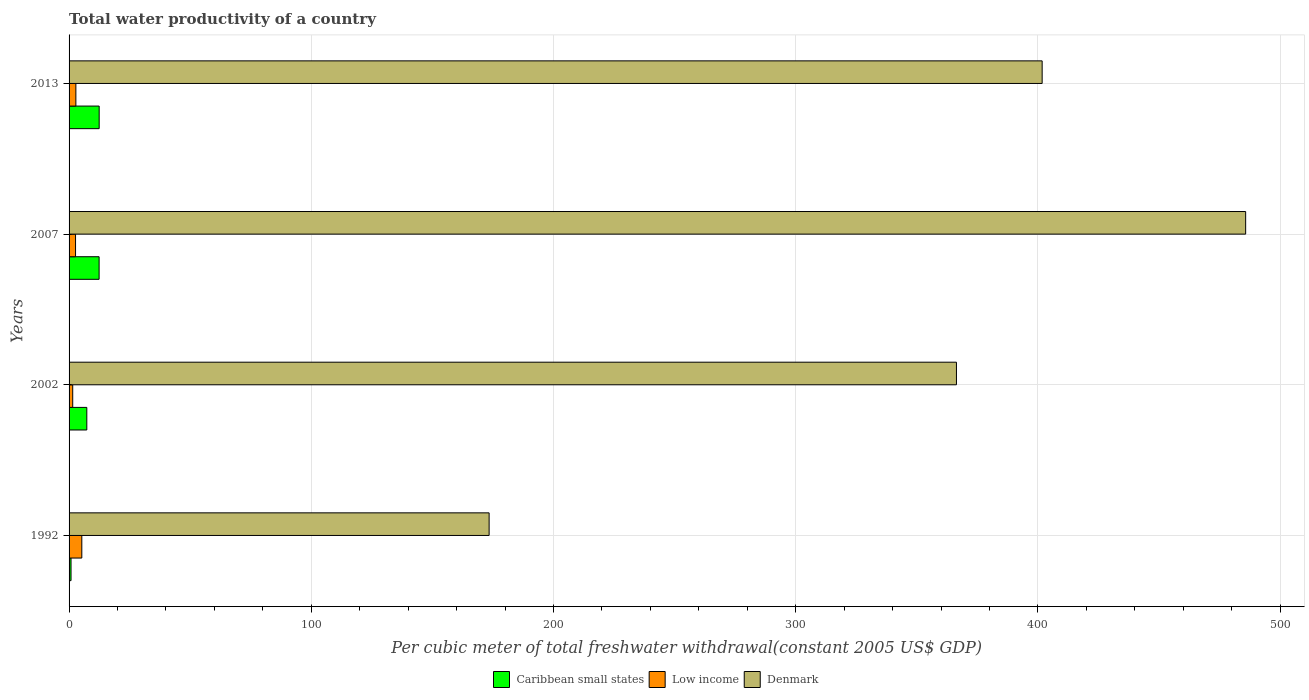How many groups of bars are there?
Your answer should be very brief. 4. How many bars are there on the 1st tick from the bottom?
Your answer should be compact. 3. What is the total water productivity in Caribbean small states in 1992?
Make the answer very short. 0.81. Across all years, what is the maximum total water productivity in Caribbean small states?
Ensure brevity in your answer.  12.43. Across all years, what is the minimum total water productivity in Caribbean small states?
Ensure brevity in your answer.  0.81. In which year was the total water productivity in Caribbean small states maximum?
Your answer should be compact. 2013. What is the total total water productivity in Caribbean small states in the graph?
Offer a terse response. 32.95. What is the difference between the total water productivity in Denmark in 2007 and that in 2013?
Make the answer very short. 84.01. What is the difference between the total water productivity in Low income in 1992 and the total water productivity in Denmark in 2007?
Keep it short and to the point. -480.47. What is the average total water productivity in Low income per year?
Make the answer very short. 3.06. In the year 2007, what is the difference between the total water productivity in Denmark and total water productivity in Low income?
Give a very brief answer. 483.06. What is the ratio of the total water productivity in Low income in 2002 to that in 2007?
Offer a terse response. 0.56. What is the difference between the highest and the second highest total water productivity in Caribbean small states?
Provide a succinct answer. 0.03. What is the difference between the highest and the lowest total water productivity in Denmark?
Give a very brief answer. 312.32. In how many years, is the total water productivity in Low income greater than the average total water productivity in Low income taken over all years?
Ensure brevity in your answer.  1. What does the 2nd bar from the top in 2002 represents?
Your answer should be very brief. Low income. Is it the case that in every year, the sum of the total water productivity in Caribbean small states and total water productivity in Denmark is greater than the total water productivity in Low income?
Your response must be concise. Yes. How many bars are there?
Make the answer very short. 12. Are all the bars in the graph horizontal?
Your response must be concise. Yes. How many years are there in the graph?
Your response must be concise. 4. Does the graph contain grids?
Make the answer very short. Yes. Where does the legend appear in the graph?
Keep it short and to the point. Bottom center. How are the legend labels stacked?
Offer a terse response. Horizontal. What is the title of the graph?
Provide a succinct answer. Total water productivity of a country. Does "Cabo Verde" appear as one of the legend labels in the graph?
Provide a succinct answer. No. What is the label or title of the X-axis?
Provide a short and direct response. Per cubic meter of total freshwater withdrawal(constant 2005 US$ GDP). What is the label or title of the Y-axis?
Make the answer very short. Years. What is the Per cubic meter of total freshwater withdrawal(constant 2005 US$ GDP) of Caribbean small states in 1992?
Keep it short and to the point. 0.81. What is the Per cubic meter of total freshwater withdrawal(constant 2005 US$ GDP) of Low income in 1992?
Ensure brevity in your answer.  5.26. What is the Per cubic meter of total freshwater withdrawal(constant 2005 US$ GDP) of Denmark in 1992?
Offer a very short reply. 173.41. What is the Per cubic meter of total freshwater withdrawal(constant 2005 US$ GDP) of Caribbean small states in 2002?
Ensure brevity in your answer.  7.32. What is the Per cubic meter of total freshwater withdrawal(constant 2005 US$ GDP) of Low income in 2002?
Offer a very short reply. 1.51. What is the Per cubic meter of total freshwater withdrawal(constant 2005 US$ GDP) of Denmark in 2002?
Keep it short and to the point. 366.34. What is the Per cubic meter of total freshwater withdrawal(constant 2005 US$ GDP) in Caribbean small states in 2007?
Provide a succinct answer. 12.4. What is the Per cubic meter of total freshwater withdrawal(constant 2005 US$ GDP) of Low income in 2007?
Offer a terse response. 2.67. What is the Per cubic meter of total freshwater withdrawal(constant 2005 US$ GDP) in Denmark in 2007?
Make the answer very short. 485.73. What is the Per cubic meter of total freshwater withdrawal(constant 2005 US$ GDP) in Caribbean small states in 2013?
Provide a succinct answer. 12.43. What is the Per cubic meter of total freshwater withdrawal(constant 2005 US$ GDP) in Low income in 2013?
Offer a very short reply. 2.81. What is the Per cubic meter of total freshwater withdrawal(constant 2005 US$ GDP) of Denmark in 2013?
Make the answer very short. 401.72. Across all years, what is the maximum Per cubic meter of total freshwater withdrawal(constant 2005 US$ GDP) of Caribbean small states?
Your answer should be compact. 12.43. Across all years, what is the maximum Per cubic meter of total freshwater withdrawal(constant 2005 US$ GDP) in Low income?
Ensure brevity in your answer.  5.26. Across all years, what is the maximum Per cubic meter of total freshwater withdrawal(constant 2005 US$ GDP) in Denmark?
Keep it short and to the point. 485.73. Across all years, what is the minimum Per cubic meter of total freshwater withdrawal(constant 2005 US$ GDP) in Caribbean small states?
Your answer should be very brief. 0.81. Across all years, what is the minimum Per cubic meter of total freshwater withdrawal(constant 2005 US$ GDP) in Low income?
Offer a terse response. 1.51. Across all years, what is the minimum Per cubic meter of total freshwater withdrawal(constant 2005 US$ GDP) in Denmark?
Offer a very short reply. 173.41. What is the total Per cubic meter of total freshwater withdrawal(constant 2005 US$ GDP) of Caribbean small states in the graph?
Provide a succinct answer. 32.95. What is the total Per cubic meter of total freshwater withdrawal(constant 2005 US$ GDP) in Low income in the graph?
Make the answer very short. 12.26. What is the total Per cubic meter of total freshwater withdrawal(constant 2005 US$ GDP) of Denmark in the graph?
Provide a succinct answer. 1427.21. What is the difference between the Per cubic meter of total freshwater withdrawal(constant 2005 US$ GDP) in Caribbean small states in 1992 and that in 2002?
Provide a succinct answer. -6.51. What is the difference between the Per cubic meter of total freshwater withdrawal(constant 2005 US$ GDP) of Low income in 1992 and that in 2002?
Provide a succinct answer. 3.75. What is the difference between the Per cubic meter of total freshwater withdrawal(constant 2005 US$ GDP) in Denmark in 1992 and that in 2002?
Your answer should be very brief. -192.92. What is the difference between the Per cubic meter of total freshwater withdrawal(constant 2005 US$ GDP) in Caribbean small states in 1992 and that in 2007?
Keep it short and to the point. -11.59. What is the difference between the Per cubic meter of total freshwater withdrawal(constant 2005 US$ GDP) in Low income in 1992 and that in 2007?
Your response must be concise. 2.59. What is the difference between the Per cubic meter of total freshwater withdrawal(constant 2005 US$ GDP) of Denmark in 1992 and that in 2007?
Keep it short and to the point. -312.32. What is the difference between the Per cubic meter of total freshwater withdrawal(constant 2005 US$ GDP) in Caribbean small states in 1992 and that in 2013?
Your answer should be very brief. -11.62. What is the difference between the Per cubic meter of total freshwater withdrawal(constant 2005 US$ GDP) of Low income in 1992 and that in 2013?
Your response must be concise. 2.45. What is the difference between the Per cubic meter of total freshwater withdrawal(constant 2005 US$ GDP) in Denmark in 1992 and that in 2013?
Provide a succinct answer. -228.31. What is the difference between the Per cubic meter of total freshwater withdrawal(constant 2005 US$ GDP) in Caribbean small states in 2002 and that in 2007?
Make the answer very short. -5.08. What is the difference between the Per cubic meter of total freshwater withdrawal(constant 2005 US$ GDP) of Low income in 2002 and that in 2007?
Your answer should be very brief. -1.17. What is the difference between the Per cubic meter of total freshwater withdrawal(constant 2005 US$ GDP) of Denmark in 2002 and that in 2007?
Provide a short and direct response. -119.4. What is the difference between the Per cubic meter of total freshwater withdrawal(constant 2005 US$ GDP) of Caribbean small states in 2002 and that in 2013?
Offer a very short reply. -5.11. What is the difference between the Per cubic meter of total freshwater withdrawal(constant 2005 US$ GDP) of Low income in 2002 and that in 2013?
Ensure brevity in your answer.  -1.3. What is the difference between the Per cubic meter of total freshwater withdrawal(constant 2005 US$ GDP) in Denmark in 2002 and that in 2013?
Provide a short and direct response. -35.39. What is the difference between the Per cubic meter of total freshwater withdrawal(constant 2005 US$ GDP) in Caribbean small states in 2007 and that in 2013?
Make the answer very short. -0.03. What is the difference between the Per cubic meter of total freshwater withdrawal(constant 2005 US$ GDP) of Low income in 2007 and that in 2013?
Your answer should be compact. -0.14. What is the difference between the Per cubic meter of total freshwater withdrawal(constant 2005 US$ GDP) in Denmark in 2007 and that in 2013?
Provide a succinct answer. 84.01. What is the difference between the Per cubic meter of total freshwater withdrawal(constant 2005 US$ GDP) of Caribbean small states in 1992 and the Per cubic meter of total freshwater withdrawal(constant 2005 US$ GDP) of Low income in 2002?
Your response must be concise. -0.7. What is the difference between the Per cubic meter of total freshwater withdrawal(constant 2005 US$ GDP) in Caribbean small states in 1992 and the Per cubic meter of total freshwater withdrawal(constant 2005 US$ GDP) in Denmark in 2002?
Provide a short and direct response. -365.53. What is the difference between the Per cubic meter of total freshwater withdrawal(constant 2005 US$ GDP) in Low income in 1992 and the Per cubic meter of total freshwater withdrawal(constant 2005 US$ GDP) in Denmark in 2002?
Ensure brevity in your answer.  -361.07. What is the difference between the Per cubic meter of total freshwater withdrawal(constant 2005 US$ GDP) in Caribbean small states in 1992 and the Per cubic meter of total freshwater withdrawal(constant 2005 US$ GDP) in Low income in 2007?
Your answer should be very brief. -1.87. What is the difference between the Per cubic meter of total freshwater withdrawal(constant 2005 US$ GDP) in Caribbean small states in 1992 and the Per cubic meter of total freshwater withdrawal(constant 2005 US$ GDP) in Denmark in 2007?
Keep it short and to the point. -484.93. What is the difference between the Per cubic meter of total freshwater withdrawal(constant 2005 US$ GDP) in Low income in 1992 and the Per cubic meter of total freshwater withdrawal(constant 2005 US$ GDP) in Denmark in 2007?
Provide a succinct answer. -480.47. What is the difference between the Per cubic meter of total freshwater withdrawal(constant 2005 US$ GDP) in Caribbean small states in 1992 and the Per cubic meter of total freshwater withdrawal(constant 2005 US$ GDP) in Low income in 2013?
Provide a short and direct response. -2.01. What is the difference between the Per cubic meter of total freshwater withdrawal(constant 2005 US$ GDP) in Caribbean small states in 1992 and the Per cubic meter of total freshwater withdrawal(constant 2005 US$ GDP) in Denmark in 2013?
Provide a succinct answer. -400.92. What is the difference between the Per cubic meter of total freshwater withdrawal(constant 2005 US$ GDP) of Low income in 1992 and the Per cubic meter of total freshwater withdrawal(constant 2005 US$ GDP) of Denmark in 2013?
Offer a terse response. -396.46. What is the difference between the Per cubic meter of total freshwater withdrawal(constant 2005 US$ GDP) of Caribbean small states in 2002 and the Per cubic meter of total freshwater withdrawal(constant 2005 US$ GDP) of Low income in 2007?
Your answer should be compact. 4.65. What is the difference between the Per cubic meter of total freshwater withdrawal(constant 2005 US$ GDP) of Caribbean small states in 2002 and the Per cubic meter of total freshwater withdrawal(constant 2005 US$ GDP) of Denmark in 2007?
Make the answer very short. -478.41. What is the difference between the Per cubic meter of total freshwater withdrawal(constant 2005 US$ GDP) in Low income in 2002 and the Per cubic meter of total freshwater withdrawal(constant 2005 US$ GDP) in Denmark in 2007?
Your response must be concise. -484.23. What is the difference between the Per cubic meter of total freshwater withdrawal(constant 2005 US$ GDP) in Caribbean small states in 2002 and the Per cubic meter of total freshwater withdrawal(constant 2005 US$ GDP) in Low income in 2013?
Your answer should be very brief. 4.51. What is the difference between the Per cubic meter of total freshwater withdrawal(constant 2005 US$ GDP) of Caribbean small states in 2002 and the Per cubic meter of total freshwater withdrawal(constant 2005 US$ GDP) of Denmark in 2013?
Your answer should be very brief. -394.4. What is the difference between the Per cubic meter of total freshwater withdrawal(constant 2005 US$ GDP) in Low income in 2002 and the Per cubic meter of total freshwater withdrawal(constant 2005 US$ GDP) in Denmark in 2013?
Make the answer very short. -400.21. What is the difference between the Per cubic meter of total freshwater withdrawal(constant 2005 US$ GDP) in Caribbean small states in 2007 and the Per cubic meter of total freshwater withdrawal(constant 2005 US$ GDP) in Low income in 2013?
Offer a terse response. 9.59. What is the difference between the Per cubic meter of total freshwater withdrawal(constant 2005 US$ GDP) of Caribbean small states in 2007 and the Per cubic meter of total freshwater withdrawal(constant 2005 US$ GDP) of Denmark in 2013?
Your answer should be very brief. -389.32. What is the difference between the Per cubic meter of total freshwater withdrawal(constant 2005 US$ GDP) in Low income in 2007 and the Per cubic meter of total freshwater withdrawal(constant 2005 US$ GDP) in Denmark in 2013?
Ensure brevity in your answer.  -399.05. What is the average Per cubic meter of total freshwater withdrawal(constant 2005 US$ GDP) in Caribbean small states per year?
Provide a succinct answer. 8.24. What is the average Per cubic meter of total freshwater withdrawal(constant 2005 US$ GDP) in Low income per year?
Make the answer very short. 3.06. What is the average Per cubic meter of total freshwater withdrawal(constant 2005 US$ GDP) in Denmark per year?
Provide a succinct answer. 356.8. In the year 1992, what is the difference between the Per cubic meter of total freshwater withdrawal(constant 2005 US$ GDP) in Caribbean small states and Per cubic meter of total freshwater withdrawal(constant 2005 US$ GDP) in Low income?
Ensure brevity in your answer.  -4.46. In the year 1992, what is the difference between the Per cubic meter of total freshwater withdrawal(constant 2005 US$ GDP) of Caribbean small states and Per cubic meter of total freshwater withdrawal(constant 2005 US$ GDP) of Denmark?
Give a very brief answer. -172.61. In the year 1992, what is the difference between the Per cubic meter of total freshwater withdrawal(constant 2005 US$ GDP) in Low income and Per cubic meter of total freshwater withdrawal(constant 2005 US$ GDP) in Denmark?
Provide a succinct answer. -168.15. In the year 2002, what is the difference between the Per cubic meter of total freshwater withdrawal(constant 2005 US$ GDP) in Caribbean small states and Per cubic meter of total freshwater withdrawal(constant 2005 US$ GDP) in Low income?
Provide a short and direct response. 5.81. In the year 2002, what is the difference between the Per cubic meter of total freshwater withdrawal(constant 2005 US$ GDP) of Caribbean small states and Per cubic meter of total freshwater withdrawal(constant 2005 US$ GDP) of Denmark?
Give a very brief answer. -359.02. In the year 2002, what is the difference between the Per cubic meter of total freshwater withdrawal(constant 2005 US$ GDP) in Low income and Per cubic meter of total freshwater withdrawal(constant 2005 US$ GDP) in Denmark?
Offer a very short reply. -364.83. In the year 2007, what is the difference between the Per cubic meter of total freshwater withdrawal(constant 2005 US$ GDP) in Caribbean small states and Per cubic meter of total freshwater withdrawal(constant 2005 US$ GDP) in Low income?
Your answer should be very brief. 9.73. In the year 2007, what is the difference between the Per cubic meter of total freshwater withdrawal(constant 2005 US$ GDP) of Caribbean small states and Per cubic meter of total freshwater withdrawal(constant 2005 US$ GDP) of Denmark?
Your answer should be very brief. -473.33. In the year 2007, what is the difference between the Per cubic meter of total freshwater withdrawal(constant 2005 US$ GDP) of Low income and Per cubic meter of total freshwater withdrawal(constant 2005 US$ GDP) of Denmark?
Provide a short and direct response. -483.06. In the year 2013, what is the difference between the Per cubic meter of total freshwater withdrawal(constant 2005 US$ GDP) of Caribbean small states and Per cubic meter of total freshwater withdrawal(constant 2005 US$ GDP) of Low income?
Offer a terse response. 9.61. In the year 2013, what is the difference between the Per cubic meter of total freshwater withdrawal(constant 2005 US$ GDP) of Caribbean small states and Per cubic meter of total freshwater withdrawal(constant 2005 US$ GDP) of Denmark?
Offer a very short reply. -389.3. In the year 2013, what is the difference between the Per cubic meter of total freshwater withdrawal(constant 2005 US$ GDP) in Low income and Per cubic meter of total freshwater withdrawal(constant 2005 US$ GDP) in Denmark?
Make the answer very short. -398.91. What is the ratio of the Per cubic meter of total freshwater withdrawal(constant 2005 US$ GDP) of Caribbean small states in 1992 to that in 2002?
Your answer should be compact. 0.11. What is the ratio of the Per cubic meter of total freshwater withdrawal(constant 2005 US$ GDP) of Low income in 1992 to that in 2002?
Make the answer very short. 3.49. What is the ratio of the Per cubic meter of total freshwater withdrawal(constant 2005 US$ GDP) in Denmark in 1992 to that in 2002?
Ensure brevity in your answer.  0.47. What is the ratio of the Per cubic meter of total freshwater withdrawal(constant 2005 US$ GDP) in Caribbean small states in 1992 to that in 2007?
Give a very brief answer. 0.07. What is the ratio of the Per cubic meter of total freshwater withdrawal(constant 2005 US$ GDP) of Low income in 1992 to that in 2007?
Provide a succinct answer. 1.97. What is the ratio of the Per cubic meter of total freshwater withdrawal(constant 2005 US$ GDP) in Denmark in 1992 to that in 2007?
Ensure brevity in your answer.  0.36. What is the ratio of the Per cubic meter of total freshwater withdrawal(constant 2005 US$ GDP) in Caribbean small states in 1992 to that in 2013?
Offer a terse response. 0.06. What is the ratio of the Per cubic meter of total freshwater withdrawal(constant 2005 US$ GDP) in Low income in 1992 to that in 2013?
Your answer should be compact. 1.87. What is the ratio of the Per cubic meter of total freshwater withdrawal(constant 2005 US$ GDP) in Denmark in 1992 to that in 2013?
Give a very brief answer. 0.43. What is the ratio of the Per cubic meter of total freshwater withdrawal(constant 2005 US$ GDP) of Caribbean small states in 2002 to that in 2007?
Your answer should be compact. 0.59. What is the ratio of the Per cubic meter of total freshwater withdrawal(constant 2005 US$ GDP) in Low income in 2002 to that in 2007?
Keep it short and to the point. 0.56. What is the ratio of the Per cubic meter of total freshwater withdrawal(constant 2005 US$ GDP) of Denmark in 2002 to that in 2007?
Your answer should be very brief. 0.75. What is the ratio of the Per cubic meter of total freshwater withdrawal(constant 2005 US$ GDP) of Caribbean small states in 2002 to that in 2013?
Offer a terse response. 0.59. What is the ratio of the Per cubic meter of total freshwater withdrawal(constant 2005 US$ GDP) in Low income in 2002 to that in 2013?
Your answer should be very brief. 0.54. What is the ratio of the Per cubic meter of total freshwater withdrawal(constant 2005 US$ GDP) of Denmark in 2002 to that in 2013?
Ensure brevity in your answer.  0.91. What is the ratio of the Per cubic meter of total freshwater withdrawal(constant 2005 US$ GDP) in Caribbean small states in 2007 to that in 2013?
Ensure brevity in your answer.  1. What is the ratio of the Per cubic meter of total freshwater withdrawal(constant 2005 US$ GDP) in Low income in 2007 to that in 2013?
Offer a terse response. 0.95. What is the ratio of the Per cubic meter of total freshwater withdrawal(constant 2005 US$ GDP) in Denmark in 2007 to that in 2013?
Provide a short and direct response. 1.21. What is the difference between the highest and the second highest Per cubic meter of total freshwater withdrawal(constant 2005 US$ GDP) of Caribbean small states?
Offer a terse response. 0.03. What is the difference between the highest and the second highest Per cubic meter of total freshwater withdrawal(constant 2005 US$ GDP) in Low income?
Ensure brevity in your answer.  2.45. What is the difference between the highest and the second highest Per cubic meter of total freshwater withdrawal(constant 2005 US$ GDP) in Denmark?
Your answer should be very brief. 84.01. What is the difference between the highest and the lowest Per cubic meter of total freshwater withdrawal(constant 2005 US$ GDP) in Caribbean small states?
Your answer should be very brief. 11.62. What is the difference between the highest and the lowest Per cubic meter of total freshwater withdrawal(constant 2005 US$ GDP) in Low income?
Provide a short and direct response. 3.75. What is the difference between the highest and the lowest Per cubic meter of total freshwater withdrawal(constant 2005 US$ GDP) in Denmark?
Your answer should be compact. 312.32. 